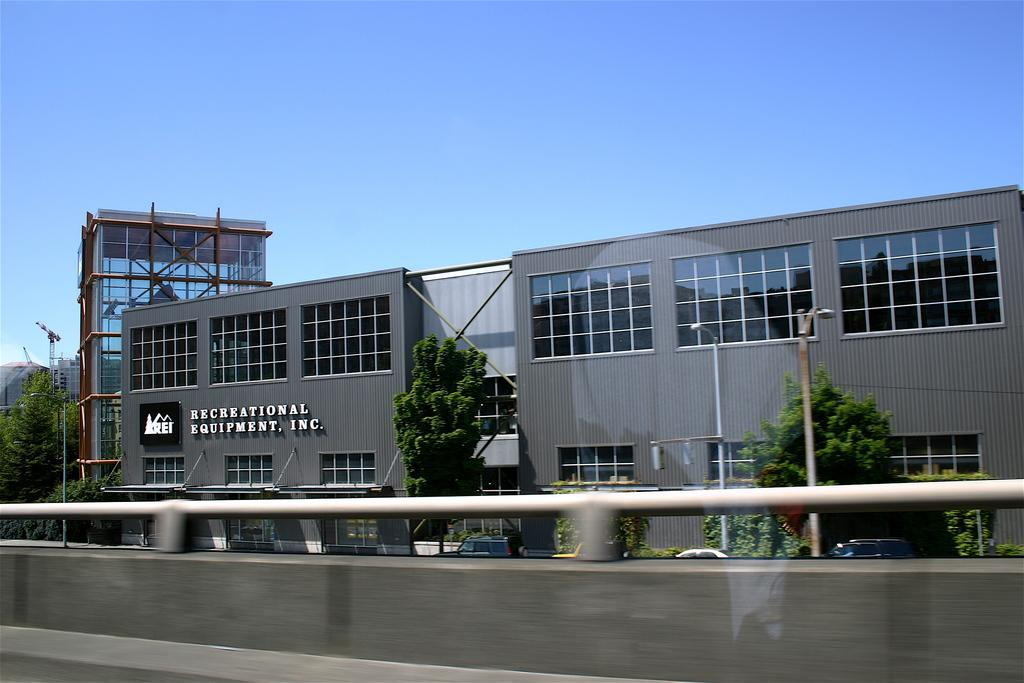What type of vegetation can be seen in the image? There are trees in the image. What color are the trees? The trees are green. What else can be seen in the image besides trees? There are light poles and buildings in the image. What is the color of the sky in the image? The sky is blue. What attempts were made to clean up the aftermath of the storm in the image? There is no mention of a storm or any aftermath in the image; it simply shows trees, light poles, buildings, and a blue sky. 